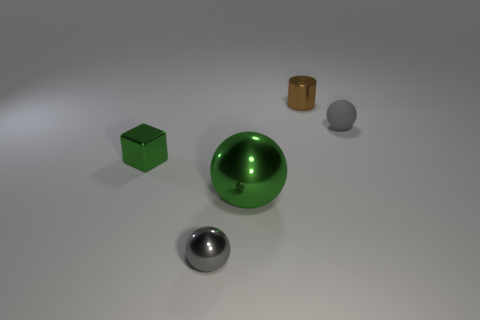Is there any other thing that is the same size as the green ball?
Make the answer very short. No. Does the tiny brown metal thing have the same shape as the gray object that is to the right of the tiny brown thing?
Make the answer very short. No. What size is the object that is behind the large green metal sphere and in front of the small gray matte sphere?
Provide a succinct answer. Small. There is a big thing; what shape is it?
Provide a short and direct response. Sphere. There is a object that is right of the small brown metal thing; is there a large sphere that is behind it?
Offer a very short reply. No. There is a tiny sphere that is on the right side of the big metallic sphere; how many green metallic spheres are left of it?
Keep it short and to the point. 1. There is a green block that is the same size as the gray rubber ball; what material is it?
Give a very brief answer. Metal. There is a tiny thing in front of the big sphere; is its shape the same as the large green shiny object?
Keep it short and to the point. Yes. Is the number of spheres right of the green shiny block greater than the number of gray rubber objects in front of the small gray metallic sphere?
Provide a succinct answer. Yes. How many other small blocks are the same material as the tiny green cube?
Your answer should be very brief. 0. 